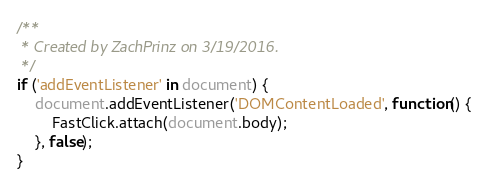Convert code to text. <code><loc_0><loc_0><loc_500><loc_500><_JavaScript_>/**
 * Created by ZachPrinz on 3/19/2016.
 */
if ('addEventListener' in document) {
    document.addEventListener('DOMContentLoaded', function() {
        FastClick.attach(document.body);
    }, false);
}</code> 